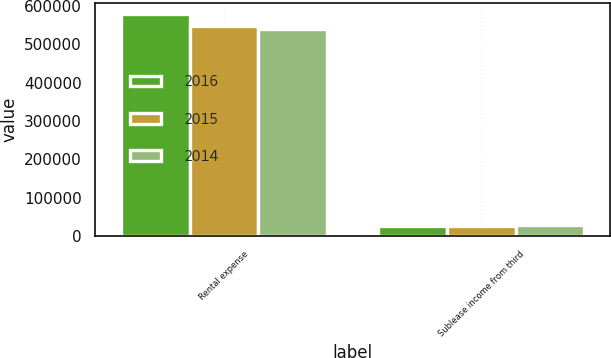Convert chart. <chart><loc_0><loc_0><loc_500><loc_500><stacked_bar_chart><ecel><fcel>Rental expense<fcel>Sublease income from third<nl><fcel>2016<fcel>578149<fcel>26403<nl><fcel>2015<fcel>547206<fcel>27293<nl><fcel>2014<fcel>539711<fcel>29482<nl></chart> 